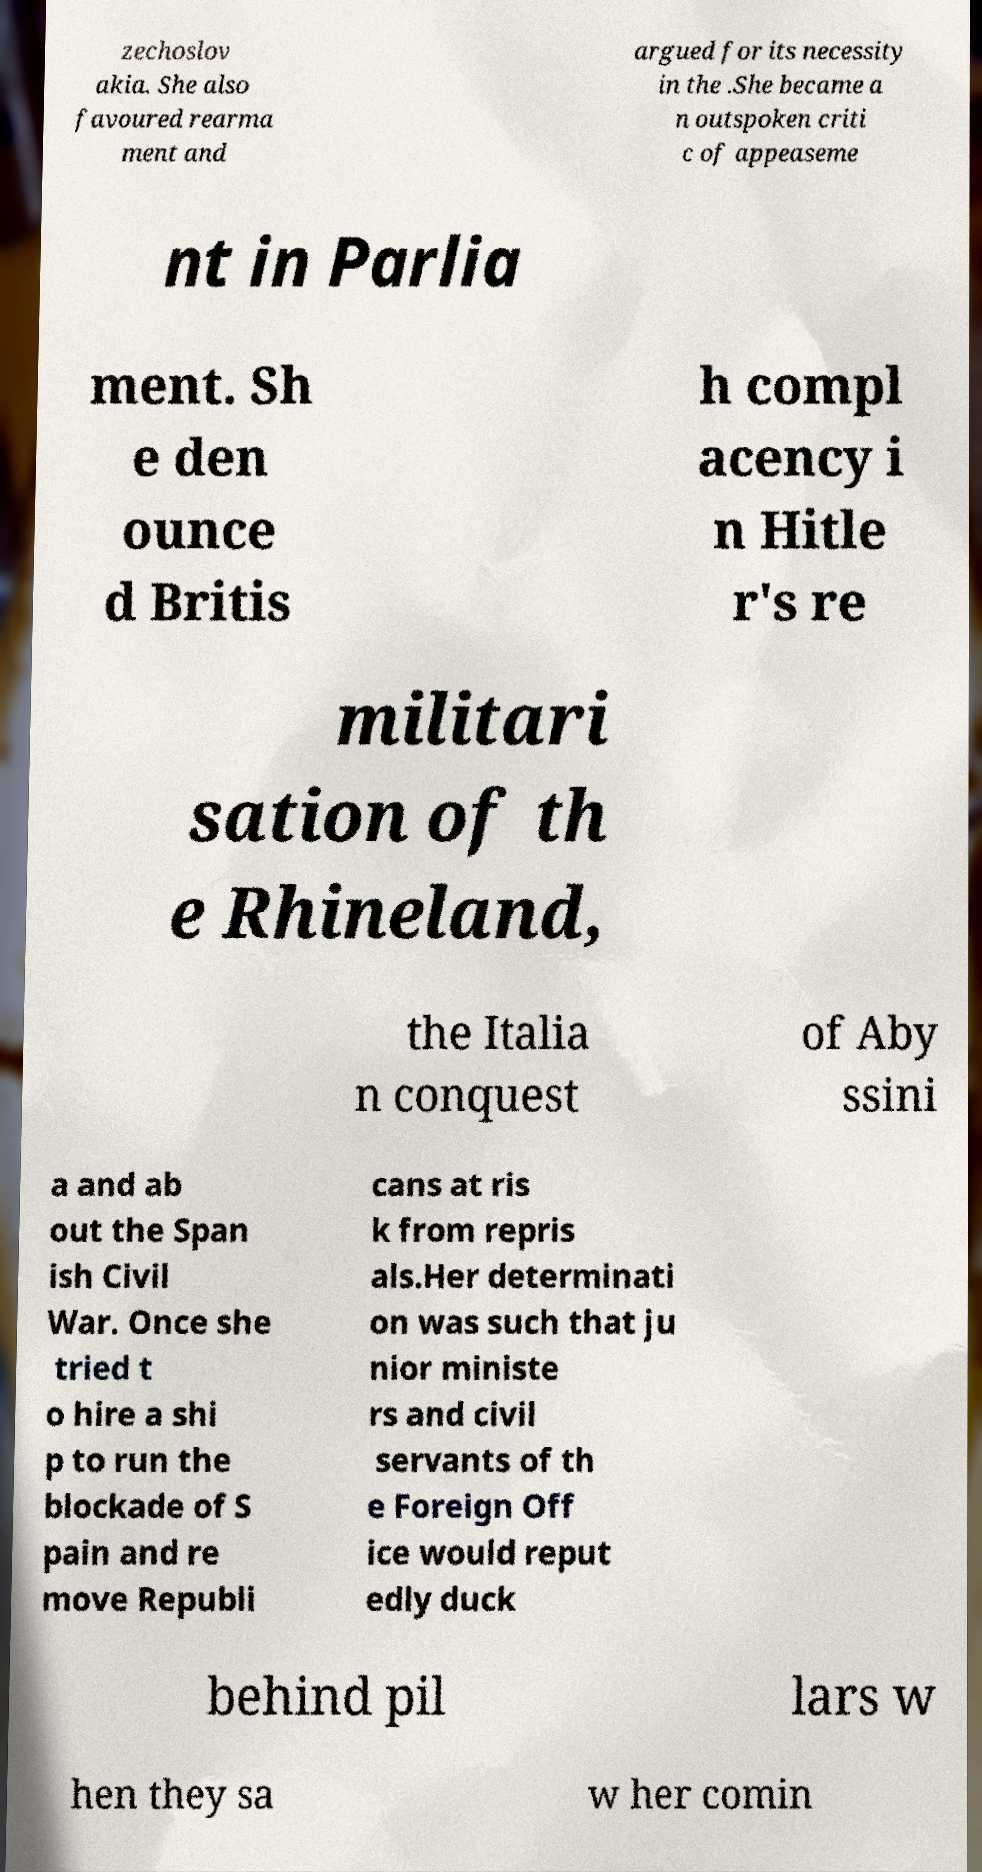Could you extract and type out the text from this image? zechoslov akia. She also favoured rearma ment and argued for its necessity in the .She became a n outspoken criti c of appeaseme nt in Parlia ment. Sh e den ounce d Britis h compl acency i n Hitle r's re militari sation of th e Rhineland, the Italia n conquest of Aby ssini a and ab out the Span ish Civil War. Once she tried t o hire a shi p to run the blockade of S pain and re move Republi cans at ris k from repris als.Her determinati on was such that ju nior ministe rs and civil servants of th e Foreign Off ice would reput edly duck behind pil lars w hen they sa w her comin 